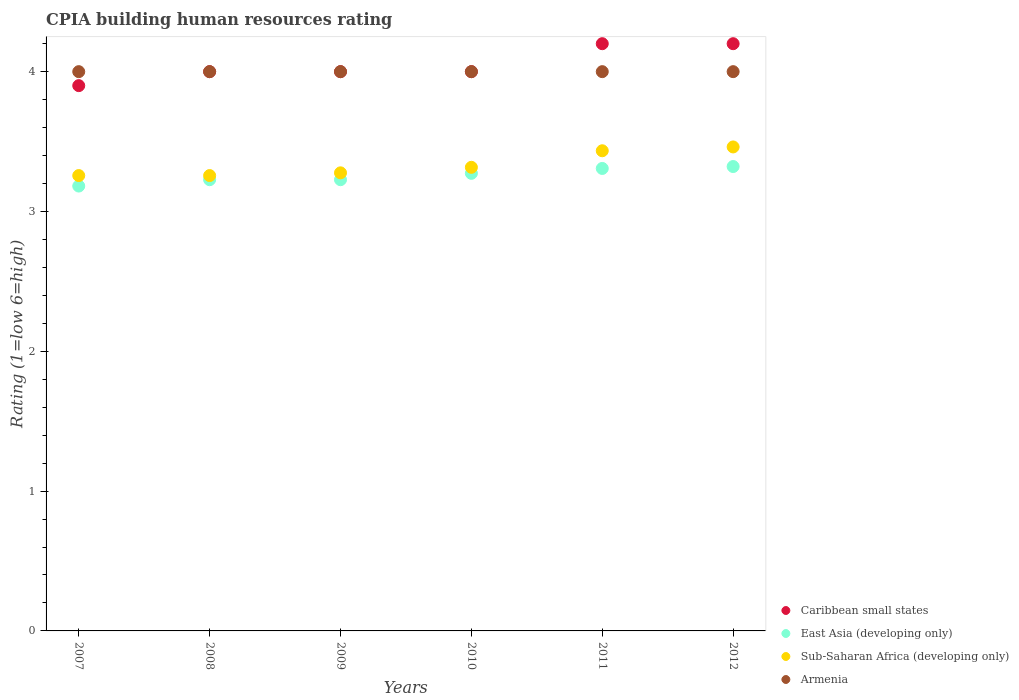How many different coloured dotlines are there?
Your answer should be compact. 4. Is the number of dotlines equal to the number of legend labels?
Ensure brevity in your answer.  Yes. What is the CPIA rating in Sub-Saharan Africa (developing only) in 2011?
Your answer should be very brief. 3.43. Across all years, what is the maximum CPIA rating in Sub-Saharan Africa (developing only)?
Ensure brevity in your answer.  3.46. Across all years, what is the minimum CPIA rating in East Asia (developing only)?
Provide a short and direct response. 3.18. In which year was the CPIA rating in Caribbean small states minimum?
Offer a very short reply. 2007. What is the total CPIA rating in Armenia in the graph?
Your answer should be compact. 24. What is the difference between the CPIA rating in Armenia in 2007 and that in 2011?
Make the answer very short. 0. What is the difference between the CPIA rating in Sub-Saharan Africa (developing only) in 2011 and the CPIA rating in Caribbean small states in 2007?
Make the answer very short. -0.47. What is the average CPIA rating in Sub-Saharan Africa (developing only) per year?
Offer a terse response. 3.33. In the year 2007, what is the difference between the CPIA rating in East Asia (developing only) and CPIA rating in Armenia?
Provide a succinct answer. -0.82. In how many years, is the CPIA rating in East Asia (developing only) greater than 3.8?
Offer a terse response. 0. What is the ratio of the CPIA rating in Sub-Saharan Africa (developing only) in 2011 to that in 2012?
Your answer should be compact. 0.99. What is the difference between the highest and the second highest CPIA rating in Armenia?
Keep it short and to the point. 0. What is the difference between the highest and the lowest CPIA rating in Armenia?
Give a very brief answer. 0. In how many years, is the CPIA rating in Caribbean small states greater than the average CPIA rating in Caribbean small states taken over all years?
Provide a succinct answer. 2. Is the sum of the CPIA rating in Armenia in 2009 and 2012 greater than the maximum CPIA rating in East Asia (developing only) across all years?
Make the answer very short. Yes. Is it the case that in every year, the sum of the CPIA rating in East Asia (developing only) and CPIA rating in Sub-Saharan Africa (developing only)  is greater than the sum of CPIA rating in Caribbean small states and CPIA rating in Armenia?
Your answer should be very brief. No. Is it the case that in every year, the sum of the CPIA rating in East Asia (developing only) and CPIA rating in Armenia  is greater than the CPIA rating in Caribbean small states?
Offer a terse response. Yes. Is the CPIA rating in Armenia strictly greater than the CPIA rating in East Asia (developing only) over the years?
Ensure brevity in your answer.  Yes. How many years are there in the graph?
Ensure brevity in your answer.  6. What is the title of the graph?
Provide a short and direct response. CPIA building human resources rating. Does "Sint Maarten (Dutch part)" appear as one of the legend labels in the graph?
Give a very brief answer. No. What is the label or title of the Y-axis?
Offer a very short reply. Rating (1=low 6=high). What is the Rating (1=low 6=high) in Caribbean small states in 2007?
Your response must be concise. 3.9. What is the Rating (1=low 6=high) in East Asia (developing only) in 2007?
Ensure brevity in your answer.  3.18. What is the Rating (1=low 6=high) of Sub-Saharan Africa (developing only) in 2007?
Your answer should be very brief. 3.26. What is the Rating (1=low 6=high) in Armenia in 2007?
Offer a very short reply. 4. What is the Rating (1=low 6=high) in East Asia (developing only) in 2008?
Keep it short and to the point. 3.23. What is the Rating (1=low 6=high) of Sub-Saharan Africa (developing only) in 2008?
Offer a very short reply. 3.26. What is the Rating (1=low 6=high) in Armenia in 2008?
Your answer should be compact. 4. What is the Rating (1=low 6=high) in Caribbean small states in 2009?
Offer a very short reply. 4. What is the Rating (1=low 6=high) in East Asia (developing only) in 2009?
Your answer should be very brief. 3.23. What is the Rating (1=low 6=high) of Sub-Saharan Africa (developing only) in 2009?
Offer a terse response. 3.28. What is the Rating (1=low 6=high) in Armenia in 2009?
Provide a succinct answer. 4. What is the Rating (1=low 6=high) of Caribbean small states in 2010?
Offer a very short reply. 4. What is the Rating (1=low 6=high) in East Asia (developing only) in 2010?
Provide a short and direct response. 3.27. What is the Rating (1=low 6=high) in Sub-Saharan Africa (developing only) in 2010?
Your answer should be compact. 3.32. What is the Rating (1=low 6=high) in Armenia in 2010?
Your answer should be very brief. 4. What is the Rating (1=low 6=high) of East Asia (developing only) in 2011?
Offer a terse response. 3.31. What is the Rating (1=low 6=high) in Sub-Saharan Africa (developing only) in 2011?
Make the answer very short. 3.43. What is the Rating (1=low 6=high) in Armenia in 2011?
Ensure brevity in your answer.  4. What is the Rating (1=low 6=high) in East Asia (developing only) in 2012?
Make the answer very short. 3.32. What is the Rating (1=low 6=high) in Sub-Saharan Africa (developing only) in 2012?
Provide a short and direct response. 3.46. What is the Rating (1=low 6=high) of Armenia in 2012?
Give a very brief answer. 4. Across all years, what is the maximum Rating (1=low 6=high) of East Asia (developing only)?
Your answer should be very brief. 3.32. Across all years, what is the maximum Rating (1=low 6=high) of Sub-Saharan Africa (developing only)?
Offer a very short reply. 3.46. Across all years, what is the minimum Rating (1=low 6=high) of East Asia (developing only)?
Offer a terse response. 3.18. Across all years, what is the minimum Rating (1=low 6=high) of Sub-Saharan Africa (developing only)?
Your answer should be very brief. 3.26. Across all years, what is the minimum Rating (1=low 6=high) of Armenia?
Give a very brief answer. 4. What is the total Rating (1=low 6=high) in Caribbean small states in the graph?
Provide a short and direct response. 24.3. What is the total Rating (1=low 6=high) in East Asia (developing only) in the graph?
Your answer should be compact. 19.54. What is the total Rating (1=low 6=high) of Sub-Saharan Africa (developing only) in the graph?
Ensure brevity in your answer.  20. What is the total Rating (1=low 6=high) in Armenia in the graph?
Keep it short and to the point. 24. What is the difference between the Rating (1=low 6=high) of Caribbean small states in 2007 and that in 2008?
Your answer should be very brief. -0.1. What is the difference between the Rating (1=low 6=high) in East Asia (developing only) in 2007 and that in 2008?
Provide a short and direct response. -0.05. What is the difference between the Rating (1=low 6=high) in Caribbean small states in 2007 and that in 2009?
Offer a very short reply. -0.1. What is the difference between the Rating (1=low 6=high) of East Asia (developing only) in 2007 and that in 2009?
Offer a very short reply. -0.05. What is the difference between the Rating (1=low 6=high) in Sub-Saharan Africa (developing only) in 2007 and that in 2009?
Offer a terse response. -0.02. What is the difference between the Rating (1=low 6=high) of East Asia (developing only) in 2007 and that in 2010?
Your answer should be compact. -0.09. What is the difference between the Rating (1=low 6=high) in Sub-Saharan Africa (developing only) in 2007 and that in 2010?
Offer a terse response. -0.06. What is the difference between the Rating (1=low 6=high) in Armenia in 2007 and that in 2010?
Make the answer very short. 0. What is the difference between the Rating (1=low 6=high) in Caribbean small states in 2007 and that in 2011?
Ensure brevity in your answer.  -0.3. What is the difference between the Rating (1=low 6=high) of East Asia (developing only) in 2007 and that in 2011?
Your response must be concise. -0.13. What is the difference between the Rating (1=low 6=high) in Sub-Saharan Africa (developing only) in 2007 and that in 2011?
Give a very brief answer. -0.18. What is the difference between the Rating (1=low 6=high) in East Asia (developing only) in 2007 and that in 2012?
Keep it short and to the point. -0.14. What is the difference between the Rating (1=low 6=high) in Sub-Saharan Africa (developing only) in 2007 and that in 2012?
Provide a short and direct response. -0.2. What is the difference between the Rating (1=low 6=high) in Armenia in 2007 and that in 2012?
Ensure brevity in your answer.  0. What is the difference between the Rating (1=low 6=high) in Sub-Saharan Africa (developing only) in 2008 and that in 2009?
Ensure brevity in your answer.  -0.02. What is the difference between the Rating (1=low 6=high) of Armenia in 2008 and that in 2009?
Provide a short and direct response. 0. What is the difference between the Rating (1=low 6=high) of Caribbean small states in 2008 and that in 2010?
Keep it short and to the point. 0. What is the difference between the Rating (1=low 6=high) of East Asia (developing only) in 2008 and that in 2010?
Your response must be concise. -0.05. What is the difference between the Rating (1=low 6=high) in Sub-Saharan Africa (developing only) in 2008 and that in 2010?
Make the answer very short. -0.06. What is the difference between the Rating (1=low 6=high) in Armenia in 2008 and that in 2010?
Offer a terse response. 0. What is the difference between the Rating (1=low 6=high) in East Asia (developing only) in 2008 and that in 2011?
Offer a terse response. -0.08. What is the difference between the Rating (1=low 6=high) in Sub-Saharan Africa (developing only) in 2008 and that in 2011?
Your response must be concise. -0.18. What is the difference between the Rating (1=low 6=high) of Caribbean small states in 2008 and that in 2012?
Your response must be concise. -0.2. What is the difference between the Rating (1=low 6=high) in East Asia (developing only) in 2008 and that in 2012?
Your response must be concise. -0.09. What is the difference between the Rating (1=low 6=high) in Sub-Saharan Africa (developing only) in 2008 and that in 2012?
Ensure brevity in your answer.  -0.2. What is the difference between the Rating (1=low 6=high) in East Asia (developing only) in 2009 and that in 2010?
Your answer should be compact. -0.05. What is the difference between the Rating (1=low 6=high) in Sub-Saharan Africa (developing only) in 2009 and that in 2010?
Give a very brief answer. -0.04. What is the difference between the Rating (1=low 6=high) of Armenia in 2009 and that in 2010?
Keep it short and to the point. 0. What is the difference between the Rating (1=low 6=high) of East Asia (developing only) in 2009 and that in 2011?
Ensure brevity in your answer.  -0.08. What is the difference between the Rating (1=low 6=high) in Sub-Saharan Africa (developing only) in 2009 and that in 2011?
Offer a very short reply. -0.16. What is the difference between the Rating (1=low 6=high) of Armenia in 2009 and that in 2011?
Offer a very short reply. 0. What is the difference between the Rating (1=low 6=high) in Caribbean small states in 2009 and that in 2012?
Your answer should be very brief. -0.2. What is the difference between the Rating (1=low 6=high) in East Asia (developing only) in 2009 and that in 2012?
Provide a succinct answer. -0.09. What is the difference between the Rating (1=low 6=high) in Sub-Saharan Africa (developing only) in 2009 and that in 2012?
Make the answer very short. -0.19. What is the difference between the Rating (1=low 6=high) of East Asia (developing only) in 2010 and that in 2011?
Offer a terse response. -0.04. What is the difference between the Rating (1=low 6=high) in Sub-Saharan Africa (developing only) in 2010 and that in 2011?
Offer a very short reply. -0.12. What is the difference between the Rating (1=low 6=high) of East Asia (developing only) in 2010 and that in 2012?
Provide a succinct answer. -0.05. What is the difference between the Rating (1=low 6=high) of Sub-Saharan Africa (developing only) in 2010 and that in 2012?
Keep it short and to the point. -0.15. What is the difference between the Rating (1=low 6=high) in Armenia in 2010 and that in 2012?
Provide a short and direct response. 0. What is the difference between the Rating (1=low 6=high) in Caribbean small states in 2011 and that in 2012?
Your answer should be very brief. 0. What is the difference between the Rating (1=low 6=high) of East Asia (developing only) in 2011 and that in 2012?
Your response must be concise. -0.01. What is the difference between the Rating (1=low 6=high) in Sub-Saharan Africa (developing only) in 2011 and that in 2012?
Your response must be concise. -0.03. What is the difference between the Rating (1=low 6=high) of Armenia in 2011 and that in 2012?
Keep it short and to the point. 0. What is the difference between the Rating (1=low 6=high) of Caribbean small states in 2007 and the Rating (1=low 6=high) of East Asia (developing only) in 2008?
Keep it short and to the point. 0.67. What is the difference between the Rating (1=low 6=high) of Caribbean small states in 2007 and the Rating (1=low 6=high) of Sub-Saharan Africa (developing only) in 2008?
Provide a succinct answer. 0.64. What is the difference between the Rating (1=low 6=high) of Caribbean small states in 2007 and the Rating (1=low 6=high) of Armenia in 2008?
Give a very brief answer. -0.1. What is the difference between the Rating (1=low 6=high) in East Asia (developing only) in 2007 and the Rating (1=low 6=high) in Sub-Saharan Africa (developing only) in 2008?
Your response must be concise. -0.07. What is the difference between the Rating (1=low 6=high) of East Asia (developing only) in 2007 and the Rating (1=low 6=high) of Armenia in 2008?
Offer a terse response. -0.82. What is the difference between the Rating (1=low 6=high) of Sub-Saharan Africa (developing only) in 2007 and the Rating (1=low 6=high) of Armenia in 2008?
Provide a succinct answer. -0.74. What is the difference between the Rating (1=low 6=high) of Caribbean small states in 2007 and the Rating (1=low 6=high) of East Asia (developing only) in 2009?
Ensure brevity in your answer.  0.67. What is the difference between the Rating (1=low 6=high) of Caribbean small states in 2007 and the Rating (1=low 6=high) of Sub-Saharan Africa (developing only) in 2009?
Your answer should be compact. 0.62. What is the difference between the Rating (1=low 6=high) in Caribbean small states in 2007 and the Rating (1=low 6=high) in Armenia in 2009?
Make the answer very short. -0.1. What is the difference between the Rating (1=low 6=high) in East Asia (developing only) in 2007 and the Rating (1=low 6=high) in Sub-Saharan Africa (developing only) in 2009?
Offer a very short reply. -0.09. What is the difference between the Rating (1=low 6=high) in East Asia (developing only) in 2007 and the Rating (1=low 6=high) in Armenia in 2009?
Give a very brief answer. -0.82. What is the difference between the Rating (1=low 6=high) in Sub-Saharan Africa (developing only) in 2007 and the Rating (1=low 6=high) in Armenia in 2009?
Keep it short and to the point. -0.74. What is the difference between the Rating (1=low 6=high) of Caribbean small states in 2007 and the Rating (1=low 6=high) of East Asia (developing only) in 2010?
Keep it short and to the point. 0.63. What is the difference between the Rating (1=low 6=high) of Caribbean small states in 2007 and the Rating (1=low 6=high) of Sub-Saharan Africa (developing only) in 2010?
Your answer should be compact. 0.58. What is the difference between the Rating (1=low 6=high) of Caribbean small states in 2007 and the Rating (1=low 6=high) of Armenia in 2010?
Keep it short and to the point. -0.1. What is the difference between the Rating (1=low 6=high) of East Asia (developing only) in 2007 and the Rating (1=low 6=high) of Sub-Saharan Africa (developing only) in 2010?
Make the answer very short. -0.13. What is the difference between the Rating (1=low 6=high) in East Asia (developing only) in 2007 and the Rating (1=low 6=high) in Armenia in 2010?
Keep it short and to the point. -0.82. What is the difference between the Rating (1=low 6=high) in Sub-Saharan Africa (developing only) in 2007 and the Rating (1=low 6=high) in Armenia in 2010?
Provide a short and direct response. -0.74. What is the difference between the Rating (1=low 6=high) in Caribbean small states in 2007 and the Rating (1=low 6=high) in East Asia (developing only) in 2011?
Keep it short and to the point. 0.59. What is the difference between the Rating (1=low 6=high) in Caribbean small states in 2007 and the Rating (1=low 6=high) in Sub-Saharan Africa (developing only) in 2011?
Keep it short and to the point. 0.47. What is the difference between the Rating (1=low 6=high) in Caribbean small states in 2007 and the Rating (1=low 6=high) in Armenia in 2011?
Your answer should be very brief. -0.1. What is the difference between the Rating (1=low 6=high) in East Asia (developing only) in 2007 and the Rating (1=low 6=high) in Sub-Saharan Africa (developing only) in 2011?
Give a very brief answer. -0.25. What is the difference between the Rating (1=low 6=high) in East Asia (developing only) in 2007 and the Rating (1=low 6=high) in Armenia in 2011?
Provide a succinct answer. -0.82. What is the difference between the Rating (1=low 6=high) in Sub-Saharan Africa (developing only) in 2007 and the Rating (1=low 6=high) in Armenia in 2011?
Make the answer very short. -0.74. What is the difference between the Rating (1=low 6=high) in Caribbean small states in 2007 and the Rating (1=low 6=high) in East Asia (developing only) in 2012?
Ensure brevity in your answer.  0.58. What is the difference between the Rating (1=low 6=high) in Caribbean small states in 2007 and the Rating (1=low 6=high) in Sub-Saharan Africa (developing only) in 2012?
Offer a terse response. 0.44. What is the difference between the Rating (1=low 6=high) in Caribbean small states in 2007 and the Rating (1=low 6=high) in Armenia in 2012?
Your response must be concise. -0.1. What is the difference between the Rating (1=low 6=high) of East Asia (developing only) in 2007 and the Rating (1=low 6=high) of Sub-Saharan Africa (developing only) in 2012?
Ensure brevity in your answer.  -0.28. What is the difference between the Rating (1=low 6=high) in East Asia (developing only) in 2007 and the Rating (1=low 6=high) in Armenia in 2012?
Provide a succinct answer. -0.82. What is the difference between the Rating (1=low 6=high) of Sub-Saharan Africa (developing only) in 2007 and the Rating (1=low 6=high) of Armenia in 2012?
Your response must be concise. -0.74. What is the difference between the Rating (1=low 6=high) of Caribbean small states in 2008 and the Rating (1=low 6=high) of East Asia (developing only) in 2009?
Your answer should be very brief. 0.77. What is the difference between the Rating (1=low 6=high) of Caribbean small states in 2008 and the Rating (1=low 6=high) of Sub-Saharan Africa (developing only) in 2009?
Ensure brevity in your answer.  0.72. What is the difference between the Rating (1=low 6=high) of Caribbean small states in 2008 and the Rating (1=low 6=high) of Armenia in 2009?
Keep it short and to the point. 0. What is the difference between the Rating (1=low 6=high) in East Asia (developing only) in 2008 and the Rating (1=low 6=high) in Sub-Saharan Africa (developing only) in 2009?
Provide a succinct answer. -0.05. What is the difference between the Rating (1=low 6=high) in East Asia (developing only) in 2008 and the Rating (1=low 6=high) in Armenia in 2009?
Provide a short and direct response. -0.77. What is the difference between the Rating (1=low 6=high) of Sub-Saharan Africa (developing only) in 2008 and the Rating (1=low 6=high) of Armenia in 2009?
Keep it short and to the point. -0.74. What is the difference between the Rating (1=low 6=high) in Caribbean small states in 2008 and the Rating (1=low 6=high) in East Asia (developing only) in 2010?
Keep it short and to the point. 0.73. What is the difference between the Rating (1=low 6=high) of Caribbean small states in 2008 and the Rating (1=low 6=high) of Sub-Saharan Africa (developing only) in 2010?
Your answer should be very brief. 0.68. What is the difference between the Rating (1=low 6=high) in East Asia (developing only) in 2008 and the Rating (1=low 6=high) in Sub-Saharan Africa (developing only) in 2010?
Offer a very short reply. -0.09. What is the difference between the Rating (1=low 6=high) in East Asia (developing only) in 2008 and the Rating (1=low 6=high) in Armenia in 2010?
Offer a very short reply. -0.77. What is the difference between the Rating (1=low 6=high) of Sub-Saharan Africa (developing only) in 2008 and the Rating (1=low 6=high) of Armenia in 2010?
Provide a short and direct response. -0.74. What is the difference between the Rating (1=low 6=high) in Caribbean small states in 2008 and the Rating (1=low 6=high) in East Asia (developing only) in 2011?
Provide a short and direct response. 0.69. What is the difference between the Rating (1=low 6=high) of Caribbean small states in 2008 and the Rating (1=low 6=high) of Sub-Saharan Africa (developing only) in 2011?
Provide a succinct answer. 0.57. What is the difference between the Rating (1=low 6=high) in Caribbean small states in 2008 and the Rating (1=low 6=high) in Armenia in 2011?
Your response must be concise. 0. What is the difference between the Rating (1=low 6=high) in East Asia (developing only) in 2008 and the Rating (1=low 6=high) in Sub-Saharan Africa (developing only) in 2011?
Provide a succinct answer. -0.21. What is the difference between the Rating (1=low 6=high) in East Asia (developing only) in 2008 and the Rating (1=low 6=high) in Armenia in 2011?
Keep it short and to the point. -0.77. What is the difference between the Rating (1=low 6=high) of Sub-Saharan Africa (developing only) in 2008 and the Rating (1=low 6=high) of Armenia in 2011?
Offer a very short reply. -0.74. What is the difference between the Rating (1=low 6=high) of Caribbean small states in 2008 and the Rating (1=low 6=high) of East Asia (developing only) in 2012?
Your answer should be very brief. 0.68. What is the difference between the Rating (1=low 6=high) of Caribbean small states in 2008 and the Rating (1=low 6=high) of Sub-Saharan Africa (developing only) in 2012?
Provide a succinct answer. 0.54. What is the difference between the Rating (1=low 6=high) of East Asia (developing only) in 2008 and the Rating (1=low 6=high) of Sub-Saharan Africa (developing only) in 2012?
Provide a succinct answer. -0.23. What is the difference between the Rating (1=low 6=high) in East Asia (developing only) in 2008 and the Rating (1=low 6=high) in Armenia in 2012?
Make the answer very short. -0.77. What is the difference between the Rating (1=low 6=high) of Sub-Saharan Africa (developing only) in 2008 and the Rating (1=low 6=high) of Armenia in 2012?
Ensure brevity in your answer.  -0.74. What is the difference between the Rating (1=low 6=high) of Caribbean small states in 2009 and the Rating (1=low 6=high) of East Asia (developing only) in 2010?
Make the answer very short. 0.73. What is the difference between the Rating (1=low 6=high) of Caribbean small states in 2009 and the Rating (1=low 6=high) of Sub-Saharan Africa (developing only) in 2010?
Your response must be concise. 0.68. What is the difference between the Rating (1=low 6=high) of East Asia (developing only) in 2009 and the Rating (1=low 6=high) of Sub-Saharan Africa (developing only) in 2010?
Your answer should be compact. -0.09. What is the difference between the Rating (1=low 6=high) in East Asia (developing only) in 2009 and the Rating (1=low 6=high) in Armenia in 2010?
Offer a terse response. -0.77. What is the difference between the Rating (1=low 6=high) in Sub-Saharan Africa (developing only) in 2009 and the Rating (1=low 6=high) in Armenia in 2010?
Your response must be concise. -0.72. What is the difference between the Rating (1=low 6=high) of Caribbean small states in 2009 and the Rating (1=low 6=high) of East Asia (developing only) in 2011?
Give a very brief answer. 0.69. What is the difference between the Rating (1=low 6=high) in Caribbean small states in 2009 and the Rating (1=low 6=high) in Sub-Saharan Africa (developing only) in 2011?
Keep it short and to the point. 0.57. What is the difference between the Rating (1=low 6=high) in Caribbean small states in 2009 and the Rating (1=low 6=high) in Armenia in 2011?
Keep it short and to the point. 0. What is the difference between the Rating (1=low 6=high) in East Asia (developing only) in 2009 and the Rating (1=low 6=high) in Sub-Saharan Africa (developing only) in 2011?
Offer a terse response. -0.21. What is the difference between the Rating (1=low 6=high) in East Asia (developing only) in 2009 and the Rating (1=low 6=high) in Armenia in 2011?
Your answer should be compact. -0.77. What is the difference between the Rating (1=low 6=high) of Sub-Saharan Africa (developing only) in 2009 and the Rating (1=low 6=high) of Armenia in 2011?
Offer a very short reply. -0.72. What is the difference between the Rating (1=low 6=high) in Caribbean small states in 2009 and the Rating (1=low 6=high) in East Asia (developing only) in 2012?
Keep it short and to the point. 0.68. What is the difference between the Rating (1=low 6=high) in Caribbean small states in 2009 and the Rating (1=low 6=high) in Sub-Saharan Africa (developing only) in 2012?
Make the answer very short. 0.54. What is the difference between the Rating (1=low 6=high) in East Asia (developing only) in 2009 and the Rating (1=low 6=high) in Sub-Saharan Africa (developing only) in 2012?
Make the answer very short. -0.23. What is the difference between the Rating (1=low 6=high) of East Asia (developing only) in 2009 and the Rating (1=low 6=high) of Armenia in 2012?
Your answer should be very brief. -0.77. What is the difference between the Rating (1=low 6=high) of Sub-Saharan Africa (developing only) in 2009 and the Rating (1=low 6=high) of Armenia in 2012?
Make the answer very short. -0.72. What is the difference between the Rating (1=low 6=high) of Caribbean small states in 2010 and the Rating (1=low 6=high) of East Asia (developing only) in 2011?
Your answer should be very brief. 0.69. What is the difference between the Rating (1=low 6=high) in Caribbean small states in 2010 and the Rating (1=low 6=high) in Sub-Saharan Africa (developing only) in 2011?
Keep it short and to the point. 0.57. What is the difference between the Rating (1=low 6=high) in East Asia (developing only) in 2010 and the Rating (1=low 6=high) in Sub-Saharan Africa (developing only) in 2011?
Offer a terse response. -0.16. What is the difference between the Rating (1=low 6=high) of East Asia (developing only) in 2010 and the Rating (1=low 6=high) of Armenia in 2011?
Your response must be concise. -0.73. What is the difference between the Rating (1=low 6=high) in Sub-Saharan Africa (developing only) in 2010 and the Rating (1=low 6=high) in Armenia in 2011?
Provide a succinct answer. -0.68. What is the difference between the Rating (1=low 6=high) in Caribbean small states in 2010 and the Rating (1=low 6=high) in East Asia (developing only) in 2012?
Your answer should be compact. 0.68. What is the difference between the Rating (1=low 6=high) of Caribbean small states in 2010 and the Rating (1=low 6=high) of Sub-Saharan Africa (developing only) in 2012?
Make the answer very short. 0.54. What is the difference between the Rating (1=low 6=high) in Caribbean small states in 2010 and the Rating (1=low 6=high) in Armenia in 2012?
Make the answer very short. 0. What is the difference between the Rating (1=low 6=high) of East Asia (developing only) in 2010 and the Rating (1=low 6=high) of Sub-Saharan Africa (developing only) in 2012?
Provide a short and direct response. -0.19. What is the difference between the Rating (1=low 6=high) of East Asia (developing only) in 2010 and the Rating (1=low 6=high) of Armenia in 2012?
Offer a terse response. -0.73. What is the difference between the Rating (1=low 6=high) of Sub-Saharan Africa (developing only) in 2010 and the Rating (1=low 6=high) of Armenia in 2012?
Your answer should be very brief. -0.68. What is the difference between the Rating (1=low 6=high) in Caribbean small states in 2011 and the Rating (1=low 6=high) in East Asia (developing only) in 2012?
Your answer should be compact. 0.88. What is the difference between the Rating (1=low 6=high) of Caribbean small states in 2011 and the Rating (1=low 6=high) of Sub-Saharan Africa (developing only) in 2012?
Ensure brevity in your answer.  0.74. What is the difference between the Rating (1=low 6=high) of East Asia (developing only) in 2011 and the Rating (1=low 6=high) of Sub-Saharan Africa (developing only) in 2012?
Provide a short and direct response. -0.15. What is the difference between the Rating (1=low 6=high) of East Asia (developing only) in 2011 and the Rating (1=low 6=high) of Armenia in 2012?
Provide a short and direct response. -0.69. What is the difference between the Rating (1=low 6=high) of Sub-Saharan Africa (developing only) in 2011 and the Rating (1=low 6=high) of Armenia in 2012?
Provide a short and direct response. -0.57. What is the average Rating (1=low 6=high) in Caribbean small states per year?
Make the answer very short. 4.05. What is the average Rating (1=low 6=high) of East Asia (developing only) per year?
Make the answer very short. 3.26. What is the average Rating (1=low 6=high) in Sub-Saharan Africa (developing only) per year?
Offer a very short reply. 3.33. What is the average Rating (1=low 6=high) in Armenia per year?
Your answer should be compact. 4. In the year 2007, what is the difference between the Rating (1=low 6=high) in Caribbean small states and Rating (1=low 6=high) in East Asia (developing only)?
Ensure brevity in your answer.  0.72. In the year 2007, what is the difference between the Rating (1=low 6=high) in Caribbean small states and Rating (1=low 6=high) in Sub-Saharan Africa (developing only)?
Make the answer very short. 0.64. In the year 2007, what is the difference between the Rating (1=low 6=high) in Caribbean small states and Rating (1=low 6=high) in Armenia?
Give a very brief answer. -0.1. In the year 2007, what is the difference between the Rating (1=low 6=high) in East Asia (developing only) and Rating (1=low 6=high) in Sub-Saharan Africa (developing only)?
Your answer should be compact. -0.07. In the year 2007, what is the difference between the Rating (1=low 6=high) of East Asia (developing only) and Rating (1=low 6=high) of Armenia?
Ensure brevity in your answer.  -0.82. In the year 2007, what is the difference between the Rating (1=low 6=high) in Sub-Saharan Africa (developing only) and Rating (1=low 6=high) in Armenia?
Provide a succinct answer. -0.74. In the year 2008, what is the difference between the Rating (1=low 6=high) in Caribbean small states and Rating (1=low 6=high) in East Asia (developing only)?
Provide a succinct answer. 0.77. In the year 2008, what is the difference between the Rating (1=low 6=high) in Caribbean small states and Rating (1=low 6=high) in Sub-Saharan Africa (developing only)?
Your answer should be very brief. 0.74. In the year 2008, what is the difference between the Rating (1=low 6=high) in Caribbean small states and Rating (1=low 6=high) in Armenia?
Keep it short and to the point. 0. In the year 2008, what is the difference between the Rating (1=low 6=high) in East Asia (developing only) and Rating (1=low 6=high) in Sub-Saharan Africa (developing only)?
Offer a terse response. -0.03. In the year 2008, what is the difference between the Rating (1=low 6=high) of East Asia (developing only) and Rating (1=low 6=high) of Armenia?
Ensure brevity in your answer.  -0.77. In the year 2008, what is the difference between the Rating (1=low 6=high) in Sub-Saharan Africa (developing only) and Rating (1=low 6=high) in Armenia?
Make the answer very short. -0.74. In the year 2009, what is the difference between the Rating (1=low 6=high) in Caribbean small states and Rating (1=low 6=high) in East Asia (developing only)?
Your response must be concise. 0.77. In the year 2009, what is the difference between the Rating (1=low 6=high) of Caribbean small states and Rating (1=low 6=high) of Sub-Saharan Africa (developing only)?
Your answer should be compact. 0.72. In the year 2009, what is the difference between the Rating (1=low 6=high) of East Asia (developing only) and Rating (1=low 6=high) of Sub-Saharan Africa (developing only)?
Offer a very short reply. -0.05. In the year 2009, what is the difference between the Rating (1=low 6=high) of East Asia (developing only) and Rating (1=low 6=high) of Armenia?
Make the answer very short. -0.77. In the year 2009, what is the difference between the Rating (1=low 6=high) in Sub-Saharan Africa (developing only) and Rating (1=low 6=high) in Armenia?
Your answer should be compact. -0.72. In the year 2010, what is the difference between the Rating (1=low 6=high) in Caribbean small states and Rating (1=low 6=high) in East Asia (developing only)?
Give a very brief answer. 0.73. In the year 2010, what is the difference between the Rating (1=low 6=high) in Caribbean small states and Rating (1=low 6=high) in Sub-Saharan Africa (developing only)?
Ensure brevity in your answer.  0.68. In the year 2010, what is the difference between the Rating (1=low 6=high) in East Asia (developing only) and Rating (1=low 6=high) in Sub-Saharan Africa (developing only)?
Provide a succinct answer. -0.04. In the year 2010, what is the difference between the Rating (1=low 6=high) in East Asia (developing only) and Rating (1=low 6=high) in Armenia?
Keep it short and to the point. -0.73. In the year 2010, what is the difference between the Rating (1=low 6=high) in Sub-Saharan Africa (developing only) and Rating (1=low 6=high) in Armenia?
Provide a succinct answer. -0.68. In the year 2011, what is the difference between the Rating (1=low 6=high) in Caribbean small states and Rating (1=low 6=high) in East Asia (developing only)?
Offer a terse response. 0.89. In the year 2011, what is the difference between the Rating (1=low 6=high) of Caribbean small states and Rating (1=low 6=high) of Sub-Saharan Africa (developing only)?
Your answer should be compact. 0.77. In the year 2011, what is the difference between the Rating (1=low 6=high) in Caribbean small states and Rating (1=low 6=high) in Armenia?
Provide a short and direct response. 0.2. In the year 2011, what is the difference between the Rating (1=low 6=high) in East Asia (developing only) and Rating (1=low 6=high) in Sub-Saharan Africa (developing only)?
Offer a terse response. -0.13. In the year 2011, what is the difference between the Rating (1=low 6=high) in East Asia (developing only) and Rating (1=low 6=high) in Armenia?
Ensure brevity in your answer.  -0.69. In the year 2011, what is the difference between the Rating (1=low 6=high) in Sub-Saharan Africa (developing only) and Rating (1=low 6=high) in Armenia?
Your response must be concise. -0.57. In the year 2012, what is the difference between the Rating (1=low 6=high) of Caribbean small states and Rating (1=low 6=high) of East Asia (developing only)?
Provide a short and direct response. 0.88. In the year 2012, what is the difference between the Rating (1=low 6=high) in Caribbean small states and Rating (1=low 6=high) in Sub-Saharan Africa (developing only)?
Provide a succinct answer. 0.74. In the year 2012, what is the difference between the Rating (1=low 6=high) in Caribbean small states and Rating (1=low 6=high) in Armenia?
Provide a short and direct response. 0.2. In the year 2012, what is the difference between the Rating (1=low 6=high) in East Asia (developing only) and Rating (1=low 6=high) in Sub-Saharan Africa (developing only)?
Ensure brevity in your answer.  -0.14. In the year 2012, what is the difference between the Rating (1=low 6=high) in East Asia (developing only) and Rating (1=low 6=high) in Armenia?
Provide a succinct answer. -0.68. In the year 2012, what is the difference between the Rating (1=low 6=high) in Sub-Saharan Africa (developing only) and Rating (1=low 6=high) in Armenia?
Your response must be concise. -0.54. What is the ratio of the Rating (1=low 6=high) of East Asia (developing only) in 2007 to that in 2008?
Your answer should be compact. 0.99. What is the ratio of the Rating (1=low 6=high) in Armenia in 2007 to that in 2008?
Your answer should be compact. 1. What is the ratio of the Rating (1=low 6=high) in Caribbean small states in 2007 to that in 2009?
Offer a terse response. 0.97. What is the ratio of the Rating (1=low 6=high) of East Asia (developing only) in 2007 to that in 2009?
Make the answer very short. 0.99. What is the ratio of the Rating (1=low 6=high) of Sub-Saharan Africa (developing only) in 2007 to that in 2009?
Keep it short and to the point. 0.99. What is the ratio of the Rating (1=low 6=high) of Armenia in 2007 to that in 2009?
Keep it short and to the point. 1. What is the ratio of the Rating (1=low 6=high) in Caribbean small states in 2007 to that in 2010?
Provide a succinct answer. 0.97. What is the ratio of the Rating (1=low 6=high) in East Asia (developing only) in 2007 to that in 2010?
Provide a succinct answer. 0.97. What is the ratio of the Rating (1=low 6=high) of Sub-Saharan Africa (developing only) in 2007 to that in 2010?
Make the answer very short. 0.98. What is the ratio of the Rating (1=low 6=high) in Caribbean small states in 2007 to that in 2011?
Make the answer very short. 0.93. What is the ratio of the Rating (1=low 6=high) of East Asia (developing only) in 2007 to that in 2011?
Provide a short and direct response. 0.96. What is the ratio of the Rating (1=low 6=high) in Sub-Saharan Africa (developing only) in 2007 to that in 2011?
Your answer should be compact. 0.95. What is the ratio of the Rating (1=low 6=high) of East Asia (developing only) in 2007 to that in 2012?
Give a very brief answer. 0.96. What is the ratio of the Rating (1=low 6=high) of Sub-Saharan Africa (developing only) in 2007 to that in 2012?
Offer a very short reply. 0.94. What is the ratio of the Rating (1=low 6=high) of Armenia in 2007 to that in 2012?
Your response must be concise. 1. What is the ratio of the Rating (1=low 6=high) in Caribbean small states in 2008 to that in 2009?
Offer a terse response. 1. What is the ratio of the Rating (1=low 6=high) of East Asia (developing only) in 2008 to that in 2010?
Offer a terse response. 0.99. What is the ratio of the Rating (1=low 6=high) in Sub-Saharan Africa (developing only) in 2008 to that in 2010?
Offer a very short reply. 0.98. What is the ratio of the Rating (1=low 6=high) of Armenia in 2008 to that in 2010?
Ensure brevity in your answer.  1. What is the ratio of the Rating (1=low 6=high) in Caribbean small states in 2008 to that in 2011?
Offer a terse response. 0.95. What is the ratio of the Rating (1=low 6=high) in East Asia (developing only) in 2008 to that in 2011?
Offer a very short reply. 0.98. What is the ratio of the Rating (1=low 6=high) in Sub-Saharan Africa (developing only) in 2008 to that in 2011?
Provide a short and direct response. 0.95. What is the ratio of the Rating (1=low 6=high) of Armenia in 2008 to that in 2011?
Make the answer very short. 1. What is the ratio of the Rating (1=low 6=high) of Caribbean small states in 2008 to that in 2012?
Your answer should be compact. 0.95. What is the ratio of the Rating (1=low 6=high) in East Asia (developing only) in 2008 to that in 2012?
Offer a very short reply. 0.97. What is the ratio of the Rating (1=low 6=high) of Sub-Saharan Africa (developing only) in 2008 to that in 2012?
Give a very brief answer. 0.94. What is the ratio of the Rating (1=low 6=high) of Armenia in 2008 to that in 2012?
Ensure brevity in your answer.  1. What is the ratio of the Rating (1=low 6=high) of Caribbean small states in 2009 to that in 2010?
Make the answer very short. 1. What is the ratio of the Rating (1=low 6=high) in East Asia (developing only) in 2009 to that in 2010?
Give a very brief answer. 0.99. What is the ratio of the Rating (1=low 6=high) in Armenia in 2009 to that in 2010?
Ensure brevity in your answer.  1. What is the ratio of the Rating (1=low 6=high) of Caribbean small states in 2009 to that in 2011?
Provide a short and direct response. 0.95. What is the ratio of the Rating (1=low 6=high) in East Asia (developing only) in 2009 to that in 2011?
Give a very brief answer. 0.98. What is the ratio of the Rating (1=low 6=high) in Sub-Saharan Africa (developing only) in 2009 to that in 2011?
Make the answer very short. 0.95. What is the ratio of the Rating (1=low 6=high) of East Asia (developing only) in 2009 to that in 2012?
Your answer should be very brief. 0.97. What is the ratio of the Rating (1=low 6=high) in Sub-Saharan Africa (developing only) in 2009 to that in 2012?
Keep it short and to the point. 0.95. What is the ratio of the Rating (1=low 6=high) in Caribbean small states in 2010 to that in 2011?
Your response must be concise. 0.95. What is the ratio of the Rating (1=low 6=high) of East Asia (developing only) in 2010 to that in 2011?
Your answer should be very brief. 0.99. What is the ratio of the Rating (1=low 6=high) of Sub-Saharan Africa (developing only) in 2010 to that in 2011?
Your response must be concise. 0.97. What is the ratio of the Rating (1=low 6=high) of Caribbean small states in 2010 to that in 2012?
Offer a very short reply. 0.95. What is the ratio of the Rating (1=low 6=high) in Sub-Saharan Africa (developing only) in 2010 to that in 2012?
Provide a short and direct response. 0.96. What is the ratio of the Rating (1=low 6=high) of Armenia in 2010 to that in 2012?
Ensure brevity in your answer.  1. What is the ratio of the Rating (1=low 6=high) of Caribbean small states in 2011 to that in 2012?
Your response must be concise. 1. What is the ratio of the Rating (1=low 6=high) of Armenia in 2011 to that in 2012?
Give a very brief answer. 1. What is the difference between the highest and the second highest Rating (1=low 6=high) in Caribbean small states?
Make the answer very short. 0. What is the difference between the highest and the second highest Rating (1=low 6=high) of East Asia (developing only)?
Offer a terse response. 0.01. What is the difference between the highest and the second highest Rating (1=low 6=high) of Sub-Saharan Africa (developing only)?
Provide a short and direct response. 0.03. What is the difference between the highest and the second highest Rating (1=low 6=high) of Armenia?
Keep it short and to the point. 0. What is the difference between the highest and the lowest Rating (1=low 6=high) in East Asia (developing only)?
Your answer should be compact. 0.14. What is the difference between the highest and the lowest Rating (1=low 6=high) of Sub-Saharan Africa (developing only)?
Provide a succinct answer. 0.2. 